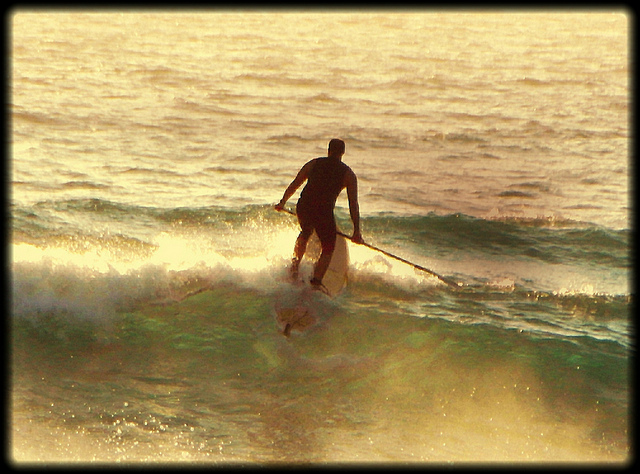Can you describe the man's clothing in the image? The man appears to be wearing a black wetsuit, which is designed to keep him warm in the cool ocean waters. The wetsuit is snug to the body, providing both insulation and protection while allowing for a wide range of movement. Why might the man choose to wear a wetsuit? A wetsuit helps maintain the body warmth in cooler ocean temperatures by trapping a thin layer of water between the suit and the skin, which gets warmed by the body. Additionally, it offers some protection against abrasions and sun exposure. What effect do you think the time of day has on this activity? Based on the lighting in the image, it looks like it might be either early morning or late afternoon when the sun is low. This time of day can provide calmer waters, fewer crowds, and a beautiful ambiance with the sunset or sunrise, making the paddleboarding experience more serene and visually stunning. 